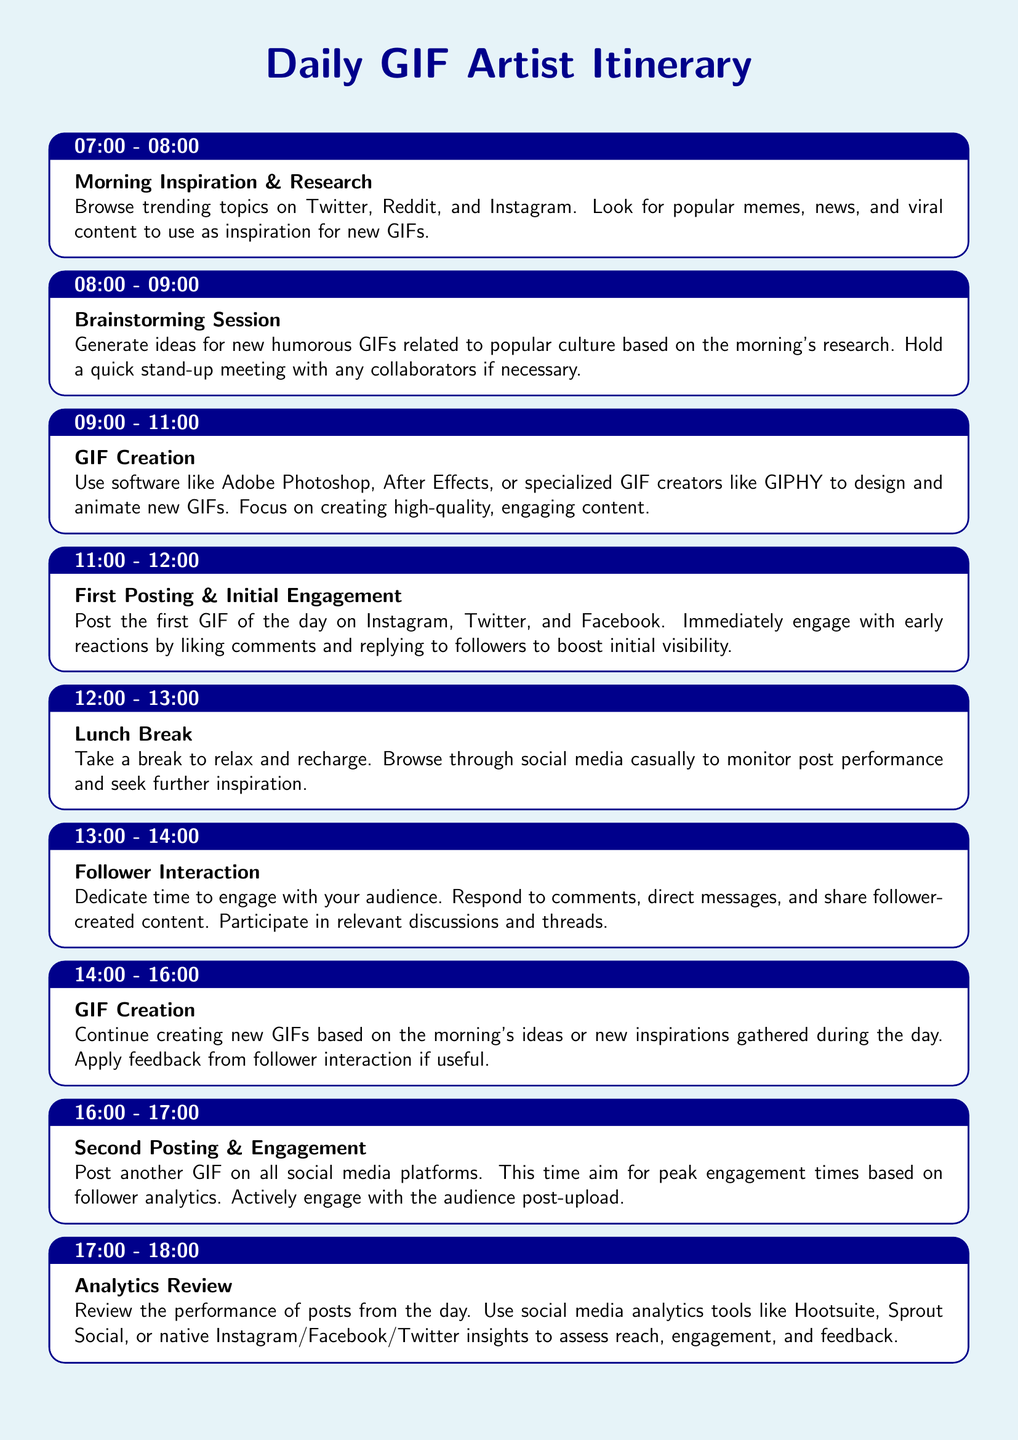What time does the day start? The day starts at 07:00 as indicated in the itinerary.
Answer: 07:00 How long is the Brainstorming Session? The duration of the Brainstorming Session is specified in the document, which is one hour.
Answer: 1 hour What software is mentioned for GIF Creation? The document lists specific software options for GIF Creation including Adobe Photoshop and After Effects.
Answer: Adobe Photoshop, After Effects When is the first posting scheduled? The itineraries mention that the first posting is scheduled for 11:00.
Answer: 11:00 What is done during the Lunch Break? The document states that the Lunch Break includes relaxing and casually browsing through social media to monitor post performance.
Answer: Relax and recharge What activity takes place between 14:00 and 16:00? The itinerary details that GIF Creation continues during this time, based on earlier ideas or new inspirations.
Answer: GIF Creation How is follower interaction conducted? The document indicates that interaction is through responding to comments and direct messages and sharing follower-created content.
Answer: Engagement with audience What is the purpose of the Analytics Review? The Analytics Review aims to assess post performance, including reach and engagement, using social media analytics tools.
Answer: Assess performance When is the Plan for Tomorrow scheduled? According to the document, planning for tomorrow occurs from 18:00 to 19:00.
Answer: 18:00 - 19:00 